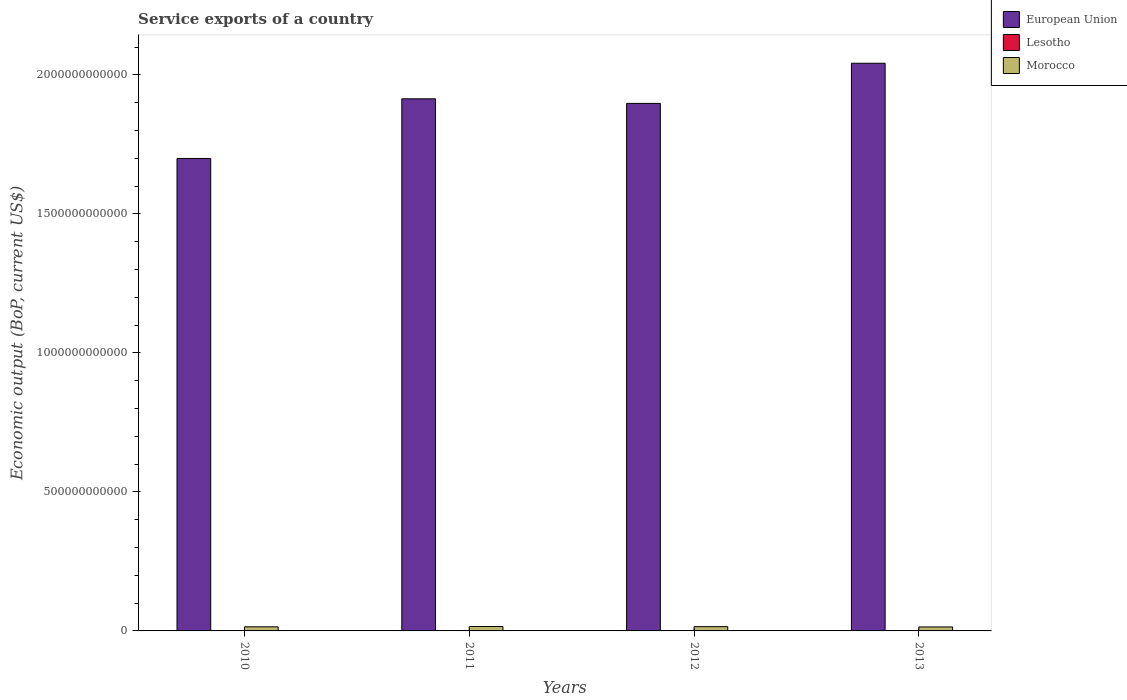How many different coloured bars are there?
Keep it short and to the point. 3. How many groups of bars are there?
Offer a very short reply. 4. Are the number of bars per tick equal to the number of legend labels?
Offer a very short reply. Yes. Are the number of bars on each tick of the X-axis equal?
Offer a very short reply. Yes. How many bars are there on the 2nd tick from the left?
Offer a terse response. 3. How many bars are there on the 1st tick from the right?
Keep it short and to the point. 3. What is the label of the 3rd group of bars from the left?
Ensure brevity in your answer.  2012. What is the service exports in Morocco in 2010?
Give a very brief answer. 1.47e+1. Across all years, what is the maximum service exports in European Union?
Your answer should be very brief. 2.04e+12. Across all years, what is the minimum service exports in Morocco?
Ensure brevity in your answer.  1.44e+1. In which year was the service exports in European Union maximum?
Your answer should be very brief. 2013. In which year was the service exports in European Union minimum?
Make the answer very short. 2010. What is the total service exports in Lesotho in the graph?
Give a very brief answer. 2.32e+08. What is the difference between the service exports in Lesotho in 2012 and that in 2013?
Your answer should be very brief. 1.26e+07. What is the difference between the service exports in Morocco in 2011 and the service exports in Lesotho in 2013?
Offer a terse response. 1.58e+1. What is the average service exports in Morocco per year?
Provide a succinct answer. 1.51e+1. In the year 2010, what is the difference between the service exports in European Union and service exports in Morocco?
Offer a terse response. 1.68e+12. What is the ratio of the service exports in Morocco in 2010 to that in 2011?
Offer a terse response. 0.93. Is the service exports in Morocco in 2010 less than that in 2013?
Offer a terse response. No. Is the difference between the service exports in European Union in 2011 and 2012 greater than the difference between the service exports in Morocco in 2011 and 2012?
Your answer should be very brief. Yes. What is the difference between the highest and the second highest service exports in Lesotho?
Your answer should be very brief. 1.26e+07. What is the difference between the highest and the lowest service exports in Lesotho?
Your response must be concise. 2.52e+07. In how many years, is the service exports in Morocco greater than the average service exports in Morocco taken over all years?
Your answer should be very brief. 2. What does the 2nd bar from the left in 2011 represents?
Give a very brief answer. Lesotho. What does the 2nd bar from the right in 2013 represents?
Ensure brevity in your answer.  Lesotho. Is it the case that in every year, the sum of the service exports in Morocco and service exports in European Union is greater than the service exports in Lesotho?
Your answer should be very brief. Yes. Are all the bars in the graph horizontal?
Provide a short and direct response. No. How many years are there in the graph?
Make the answer very short. 4. What is the difference between two consecutive major ticks on the Y-axis?
Make the answer very short. 5.00e+11. What is the title of the graph?
Provide a succinct answer. Service exports of a country. What is the label or title of the Y-axis?
Your answer should be very brief. Economic output (BoP, current US$). What is the Economic output (BoP, current US$) in European Union in 2010?
Your answer should be very brief. 1.70e+12. What is the Economic output (BoP, current US$) in Lesotho in 2010?
Provide a succinct answer. 4.77e+07. What is the Economic output (BoP, current US$) of Morocco in 2010?
Make the answer very short. 1.47e+1. What is the Economic output (BoP, current US$) of European Union in 2011?
Your answer should be very brief. 1.91e+12. What is the Economic output (BoP, current US$) of Lesotho in 2011?
Offer a very short reply. 5.08e+07. What is the Economic output (BoP, current US$) of Morocco in 2011?
Your answer should be very brief. 1.59e+1. What is the Economic output (BoP, current US$) of European Union in 2012?
Offer a very short reply. 1.90e+12. What is the Economic output (BoP, current US$) of Lesotho in 2012?
Provide a short and direct response. 7.29e+07. What is the Economic output (BoP, current US$) in Morocco in 2012?
Offer a very short reply. 1.53e+1. What is the Economic output (BoP, current US$) in European Union in 2013?
Offer a terse response. 2.04e+12. What is the Economic output (BoP, current US$) in Lesotho in 2013?
Keep it short and to the point. 6.03e+07. What is the Economic output (BoP, current US$) in Morocco in 2013?
Your response must be concise. 1.44e+1. Across all years, what is the maximum Economic output (BoP, current US$) of European Union?
Provide a short and direct response. 2.04e+12. Across all years, what is the maximum Economic output (BoP, current US$) of Lesotho?
Provide a succinct answer. 7.29e+07. Across all years, what is the maximum Economic output (BoP, current US$) of Morocco?
Offer a very short reply. 1.59e+1. Across all years, what is the minimum Economic output (BoP, current US$) in European Union?
Your answer should be very brief. 1.70e+12. Across all years, what is the minimum Economic output (BoP, current US$) in Lesotho?
Keep it short and to the point. 4.77e+07. Across all years, what is the minimum Economic output (BoP, current US$) of Morocco?
Your answer should be very brief. 1.44e+1. What is the total Economic output (BoP, current US$) in European Union in the graph?
Your answer should be compact. 7.55e+12. What is the total Economic output (BoP, current US$) in Lesotho in the graph?
Your response must be concise. 2.32e+08. What is the total Economic output (BoP, current US$) in Morocco in the graph?
Ensure brevity in your answer.  6.03e+1. What is the difference between the Economic output (BoP, current US$) in European Union in 2010 and that in 2011?
Your answer should be very brief. -2.15e+11. What is the difference between the Economic output (BoP, current US$) of Lesotho in 2010 and that in 2011?
Your response must be concise. -3.10e+06. What is the difference between the Economic output (BoP, current US$) of Morocco in 2010 and that in 2011?
Your answer should be very brief. -1.16e+09. What is the difference between the Economic output (BoP, current US$) in European Union in 2010 and that in 2012?
Offer a very short reply. -1.98e+11. What is the difference between the Economic output (BoP, current US$) in Lesotho in 2010 and that in 2012?
Provide a short and direct response. -2.52e+07. What is the difference between the Economic output (BoP, current US$) in Morocco in 2010 and that in 2012?
Offer a very short reply. -6.11e+08. What is the difference between the Economic output (BoP, current US$) in European Union in 2010 and that in 2013?
Offer a terse response. -3.42e+11. What is the difference between the Economic output (BoP, current US$) in Lesotho in 2010 and that in 2013?
Offer a very short reply. -1.26e+07. What is the difference between the Economic output (BoP, current US$) of Morocco in 2010 and that in 2013?
Give a very brief answer. 3.83e+08. What is the difference between the Economic output (BoP, current US$) of European Union in 2011 and that in 2012?
Keep it short and to the point. 1.65e+1. What is the difference between the Economic output (BoP, current US$) in Lesotho in 2011 and that in 2012?
Keep it short and to the point. -2.21e+07. What is the difference between the Economic output (BoP, current US$) of Morocco in 2011 and that in 2012?
Your answer should be compact. 5.52e+08. What is the difference between the Economic output (BoP, current US$) in European Union in 2011 and that in 2013?
Provide a short and direct response. -1.28e+11. What is the difference between the Economic output (BoP, current US$) in Lesotho in 2011 and that in 2013?
Ensure brevity in your answer.  -9.50e+06. What is the difference between the Economic output (BoP, current US$) of Morocco in 2011 and that in 2013?
Your response must be concise. 1.55e+09. What is the difference between the Economic output (BoP, current US$) in European Union in 2012 and that in 2013?
Your response must be concise. -1.44e+11. What is the difference between the Economic output (BoP, current US$) in Lesotho in 2012 and that in 2013?
Your response must be concise. 1.26e+07. What is the difference between the Economic output (BoP, current US$) in Morocco in 2012 and that in 2013?
Your response must be concise. 9.94e+08. What is the difference between the Economic output (BoP, current US$) of European Union in 2010 and the Economic output (BoP, current US$) of Lesotho in 2011?
Provide a succinct answer. 1.70e+12. What is the difference between the Economic output (BoP, current US$) in European Union in 2010 and the Economic output (BoP, current US$) in Morocco in 2011?
Keep it short and to the point. 1.68e+12. What is the difference between the Economic output (BoP, current US$) of Lesotho in 2010 and the Economic output (BoP, current US$) of Morocco in 2011?
Give a very brief answer. -1.59e+1. What is the difference between the Economic output (BoP, current US$) in European Union in 2010 and the Economic output (BoP, current US$) in Lesotho in 2012?
Your answer should be very brief. 1.70e+12. What is the difference between the Economic output (BoP, current US$) of European Union in 2010 and the Economic output (BoP, current US$) of Morocco in 2012?
Provide a succinct answer. 1.68e+12. What is the difference between the Economic output (BoP, current US$) in Lesotho in 2010 and the Economic output (BoP, current US$) in Morocco in 2012?
Keep it short and to the point. -1.53e+1. What is the difference between the Economic output (BoP, current US$) of European Union in 2010 and the Economic output (BoP, current US$) of Lesotho in 2013?
Your answer should be compact. 1.70e+12. What is the difference between the Economic output (BoP, current US$) in European Union in 2010 and the Economic output (BoP, current US$) in Morocco in 2013?
Give a very brief answer. 1.69e+12. What is the difference between the Economic output (BoP, current US$) of Lesotho in 2010 and the Economic output (BoP, current US$) of Morocco in 2013?
Your answer should be compact. -1.43e+1. What is the difference between the Economic output (BoP, current US$) of European Union in 2011 and the Economic output (BoP, current US$) of Lesotho in 2012?
Ensure brevity in your answer.  1.91e+12. What is the difference between the Economic output (BoP, current US$) in European Union in 2011 and the Economic output (BoP, current US$) in Morocco in 2012?
Ensure brevity in your answer.  1.90e+12. What is the difference between the Economic output (BoP, current US$) of Lesotho in 2011 and the Economic output (BoP, current US$) of Morocco in 2012?
Make the answer very short. -1.53e+1. What is the difference between the Economic output (BoP, current US$) of European Union in 2011 and the Economic output (BoP, current US$) of Lesotho in 2013?
Your answer should be compact. 1.91e+12. What is the difference between the Economic output (BoP, current US$) in European Union in 2011 and the Economic output (BoP, current US$) in Morocco in 2013?
Your answer should be very brief. 1.90e+12. What is the difference between the Economic output (BoP, current US$) in Lesotho in 2011 and the Economic output (BoP, current US$) in Morocco in 2013?
Keep it short and to the point. -1.43e+1. What is the difference between the Economic output (BoP, current US$) of European Union in 2012 and the Economic output (BoP, current US$) of Lesotho in 2013?
Provide a short and direct response. 1.90e+12. What is the difference between the Economic output (BoP, current US$) of European Union in 2012 and the Economic output (BoP, current US$) of Morocco in 2013?
Provide a short and direct response. 1.88e+12. What is the difference between the Economic output (BoP, current US$) in Lesotho in 2012 and the Economic output (BoP, current US$) in Morocco in 2013?
Provide a short and direct response. -1.43e+1. What is the average Economic output (BoP, current US$) in European Union per year?
Your response must be concise. 1.89e+12. What is the average Economic output (BoP, current US$) of Lesotho per year?
Make the answer very short. 5.80e+07. What is the average Economic output (BoP, current US$) of Morocco per year?
Your response must be concise. 1.51e+1. In the year 2010, what is the difference between the Economic output (BoP, current US$) in European Union and Economic output (BoP, current US$) in Lesotho?
Your response must be concise. 1.70e+12. In the year 2010, what is the difference between the Economic output (BoP, current US$) in European Union and Economic output (BoP, current US$) in Morocco?
Provide a succinct answer. 1.68e+12. In the year 2010, what is the difference between the Economic output (BoP, current US$) in Lesotho and Economic output (BoP, current US$) in Morocco?
Make the answer very short. -1.47e+1. In the year 2011, what is the difference between the Economic output (BoP, current US$) of European Union and Economic output (BoP, current US$) of Lesotho?
Make the answer very short. 1.91e+12. In the year 2011, what is the difference between the Economic output (BoP, current US$) of European Union and Economic output (BoP, current US$) of Morocco?
Make the answer very short. 1.90e+12. In the year 2011, what is the difference between the Economic output (BoP, current US$) in Lesotho and Economic output (BoP, current US$) in Morocco?
Your response must be concise. -1.58e+1. In the year 2012, what is the difference between the Economic output (BoP, current US$) in European Union and Economic output (BoP, current US$) in Lesotho?
Your answer should be very brief. 1.90e+12. In the year 2012, what is the difference between the Economic output (BoP, current US$) of European Union and Economic output (BoP, current US$) of Morocco?
Your answer should be compact. 1.88e+12. In the year 2012, what is the difference between the Economic output (BoP, current US$) in Lesotho and Economic output (BoP, current US$) in Morocco?
Keep it short and to the point. -1.53e+1. In the year 2013, what is the difference between the Economic output (BoP, current US$) in European Union and Economic output (BoP, current US$) in Lesotho?
Give a very brief answer. 2.04e+12. In the year 2013, what is the difference between the Economic output (BoP, current US$) of European Union and Economic output (BoP, current US$) of Morocco?
Offer a very short reply. 2.03e+12. In the year 2013, what is the difference between the Economic output (BoP, current US$) of Lesotho and Economic output (BoP, current US$) of Morocco?
Offer a terse response. -1.43e+1. What is the ratio of the Economic output (BoP, current US$) in European Union in 2010 to that in 2011?
Provide a short and direct response. 0.89. What is the ratio of the Economic output (BoP, current US$) of Lesotho in 2010 to that in 2011?
Keep it short and to the point. 0.94. What is the ratio of the Economic output (BoP, current US$) of Morocco in 2010 to that in 2011?
Keep it short and to the point. 0.93. What is the ratio of the Economic output (BoP, current US$) of European Union in 2010 to that in 2012?
Your answer should be very brief. 0.9. What is the ratio of the Economic output (BoP, current US$) in Lesotho in 2010 to that in 2012?
Ensure brevity in your answer.  0.65. What is the ratio of the Economic output (BoP, current US$) of Morocco in 2010 to that in 2012?
Offer a very short reply. 0.96. What is the ratio of the Economic output (BoP, current US$) of European Union in 2010 to that in 2013?
Your answer should be very brief. 0.83. What is the ratio of the Economic output (BoP, current US$) of Lesotho in 2010 to that in 2013?
Your answer should be compact. 0.79. What is the ratio of the Economic output (BoP, current US$) in Morocco in 2010 to that in 2013?
Offer a terse response. 1.03. What is the ratio of the Economic output (BoP, current US$) in European Union in 2011 to that in 2012?
Offer a terse response. 1.01. What is the ratio of the Economic output (BoP, current US$) in Lesotho in 2011 to that in 2012?
Your answer should be very brief. 0.7. What is the ratio of the Economic output (BoP, current US$) of Morocco in 2011 to that in 2012?
Offer a very short reply. 1.04. What is the ratio of the Economic output (BoP, current US$) in European Union in 2011 to that in 2013?
Your answer should be compact. 0.94. What is the ratio of the Economic output (BoP, current US$) of Lesotho in 2011 to that in 2013?
Provide a short and direct response. 0.84. What is the ratio of the Economic output (BoP, current US$) of Morocco in 2011 to that in 2013?
Keep it short and to the point. 1.11. What is the ratio of the Economic output (BoP, current US$) of European Union in 2012 to that in 2013?
Your answer should be very brief. 0.93. What is the ratio of the Economic output (BoP, current US$) of Lesotho in 2012 to that in 2013?
Give a very brief answer. 1.21. What is the ratio of the Economic output (BoP, current US$) in Morocco in 2012 to that in 2013?
Your answer should be compact. 1.07. What is the difference between the highest and the second highest Economic output (BoP, current US$) in European Union?
Give a very brief answer. 1.28e+11. What is the difference between the highest and the second highest Economic output (BoP, current US$) in Lesotho?
Your answer should be compact. 1.26e+07. What is the difference between the highest and the second highest Economic output (BoP, current US$) in Morocco?
Provide a succinct answer. 5.52e+08. What is the difference between the highest and the lowest Economic output (BoP, current US$) of European Union?
Ensure brevity in your answer.  3.42e+11. What is the difference between the highest and the lowest Economic output (BoP, current US$) in Lesotho?
Make the answer very short. 2.52e+07. What is the difference between the highest and the lowest Economic output (BoP, current US$) in Morocco?
Give a very brief answer. 1.55e+09. 